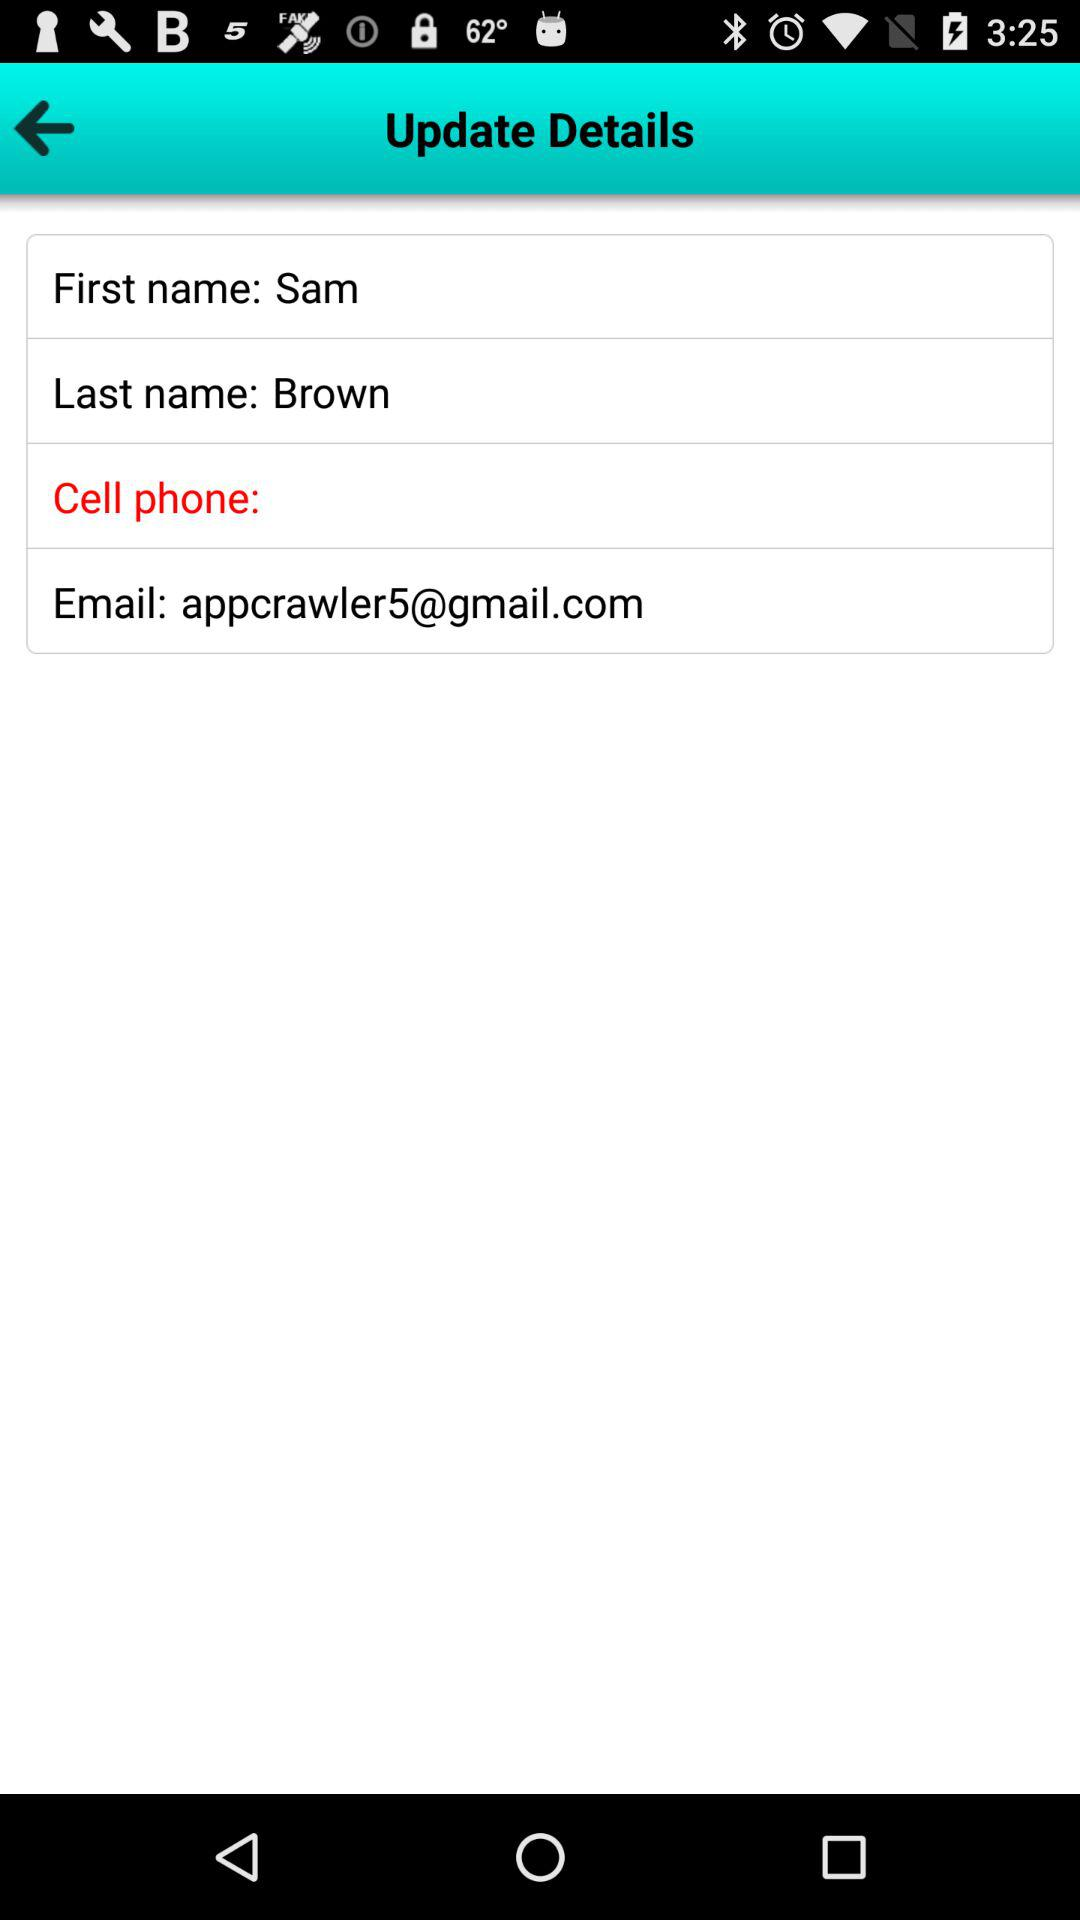How many text fields are there in the details section?
Answer the question using a single word or phrase. 4 